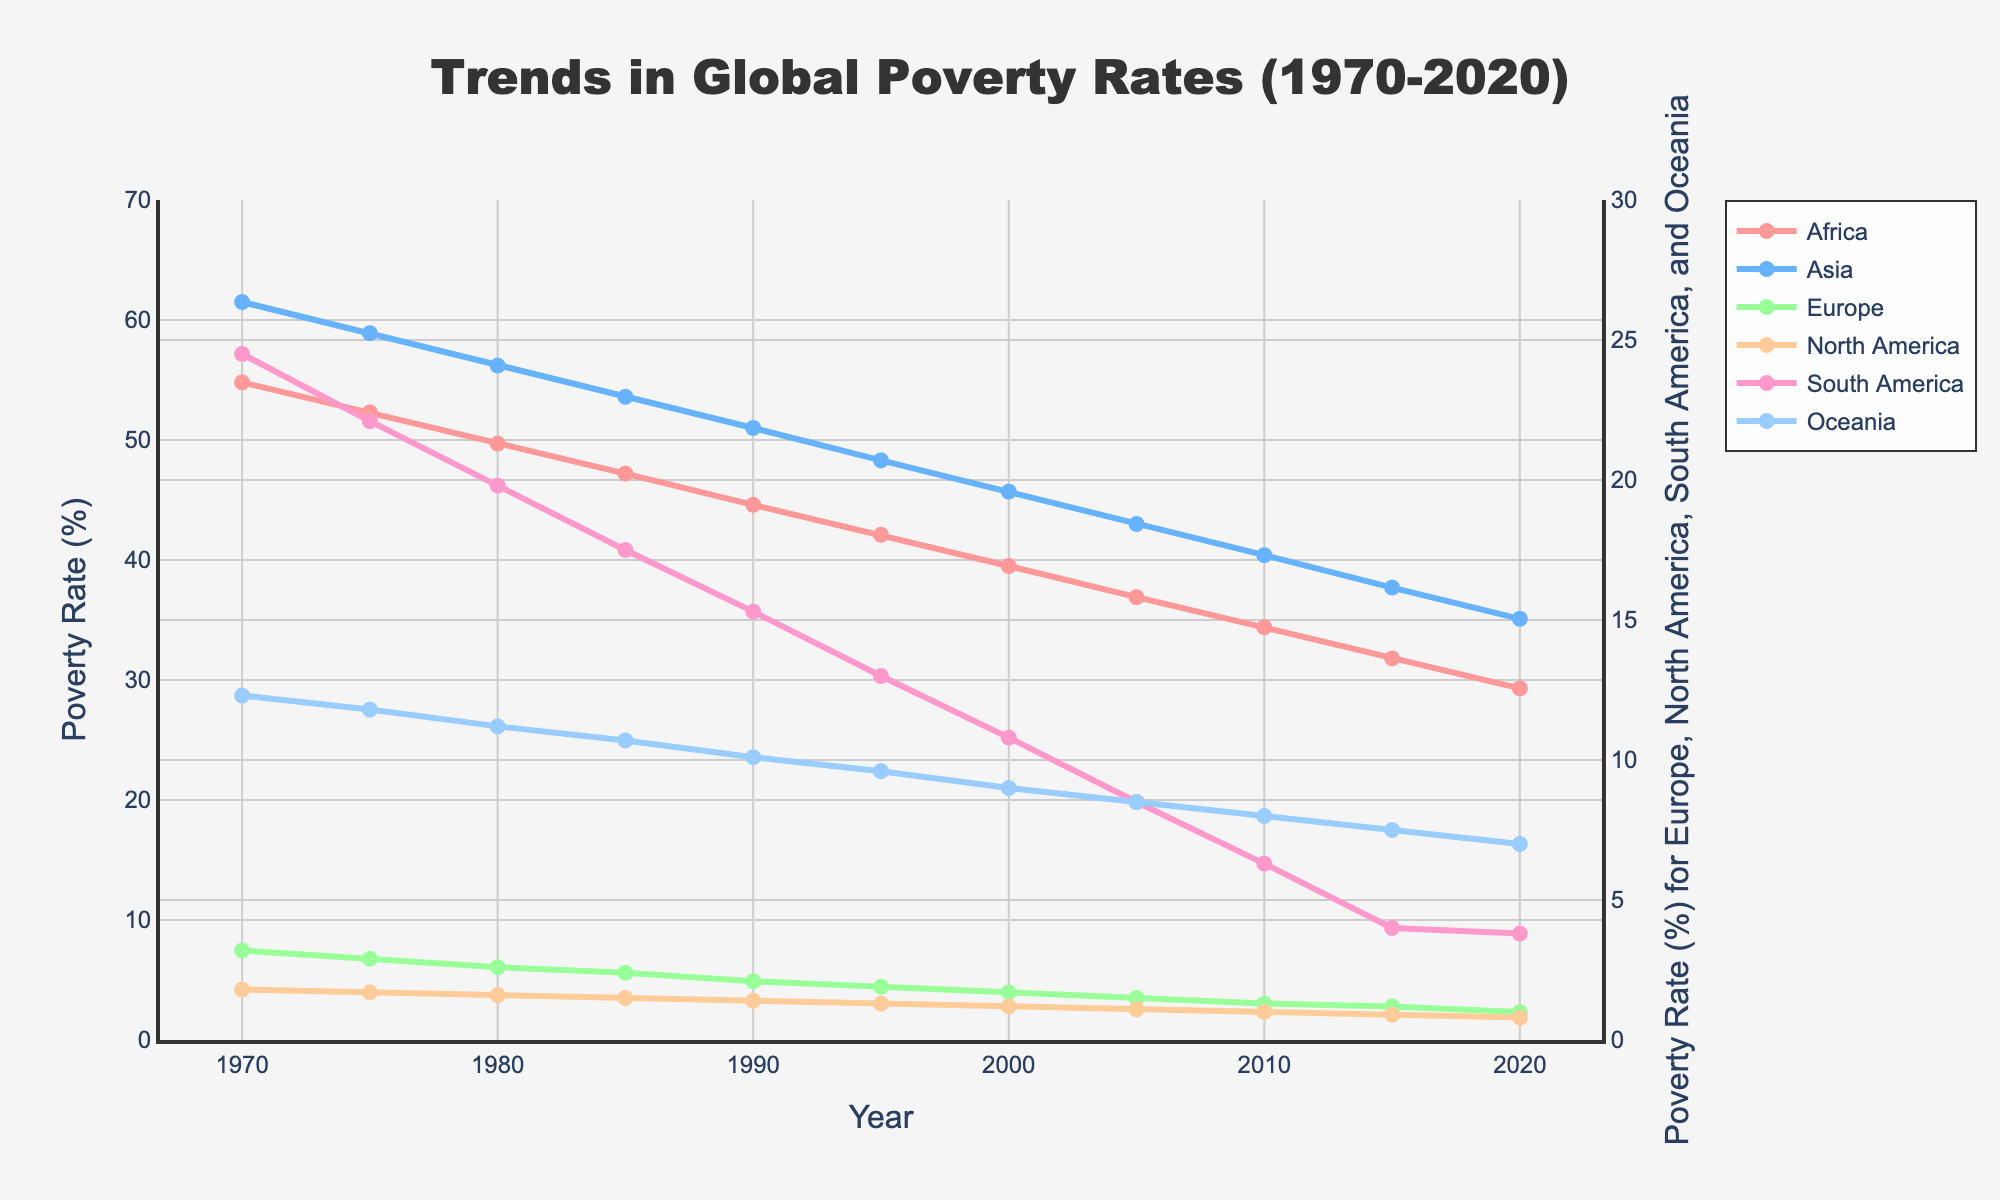What was the poverty rate in Africa in 1970 and how much did it decline by 2020? The poverty rate in Africa in 1970 was 54.8%, and in 2020 it was 29.3%. The decline is calculated as 54.8% - 29.3% = 25.5%.
Answer: 25.5% How do the poverty rates in Asia and Africa compare in 1980? In 1980, the poverty rate in Asia was 56.2%, and in Africa, it was 49.7%. Comparing these rates: 56.2% (Asia) > 49.7% (Africa).
Answer: Asia is greater Which continent had the lowest poverty rate in 2020? By examining the poverty rates in 2020, Europe had the lowest poverty rate at 1.0%.
Answer: Europe What is the average poverty rate across all continents in 1990? The poverty rates in 1990 were Africa: 44.6%, Asia: 51.0%, Europe: 2.1%, North America: 1.4%, South America: 15.3%, Oceania: 10.1%. The sum is 44.6 + 51.0 + 2.1 + 1.4 + 15.3 + 10.1 = 124.5. Dividing by 6 gives an average of 124.5 / 6 ≈ 20.75%.
Answer: 20.75% How does the declining trend in poverty rates in South America from 1970 to 2020 compare to that in Oceania? South America's poverty rate declined from 24.5% to 3.8%, a difference of 24.5% - 3.8% = 20.7%. Oceania's rate declined from 12.3% to 7.0%, a difference of 12.3% - 7.0% = 5.3%. South America's decline (20.7%) is greater than Oceania's (5.3%).
Answer: South America's decline is greater Which continents show a declining trend in poverty rates over the entire period? All continents (Africa, Asia, Europe, North America, South America, Oceania) show a declining trend as each line consistently decreases from 1970 to 2020.
Answer: All continents By how much did the poverty rate in North America change from 1990 to 2020? The poverty rate in North America in 1990 was 1.4%, and in 2020 it was 0.8%. The change is 1.4% - 0.8% = 0.6%.
Answer: 0.6% What is the difference in the poverty reduction rate between Asia and Europe over the 50-year period? Asia's poverty rate declined from 61.5% to 35.1%, a reduction of 61.5% - 35.1% = 26.4%. Europe's rate declined from 3.2% to 1.0%, a reduction of 3.2% - 1.0% = 2.2%. The difference is 26.4% - 2.2% = 24.2%.
Answer: 24.2% 